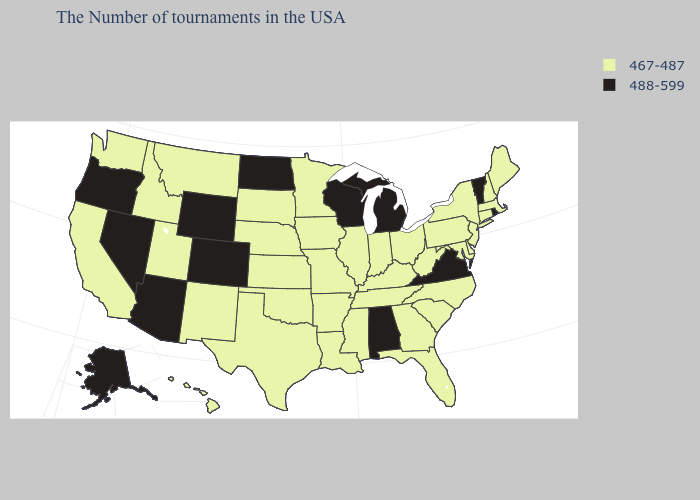Among the states that border Pennsylvania , which have the lowest value?
Short answer required. New York, New Jersey, Delaware, Maryland, West Virginia, Ohio. Does Montana have the lowest value in the West?
Write a very short answer. Yes. What is the value of Pennsylvania?
Give a very brief answer. 467-487. Which states have the lowest value in the USA?
Quick response, please. Maine, Massachusetts, New Hampshire, Connecticut, New York, New Jersey, Delaware, Maryland, Pennsylvania, North Carolina, South Carolina, West Virginia, Ohio, Florida, Georgia, Kentucky, Indiana, Tennessee, Illinois, Mississippi, Louisiana, Missouri, Arkansas, Minnesota, Iowa, Kansas, Nebraska, Oklahoma, Texas, South Dakota, New Mexico, Utah, Montana, Idaho, California, Washington, Hawaii. What is the lowest value in states that border Wyoming?
Be succinct. 467-487. Among the states that border Mississippi , which have the lowest value?
Quick response, please. Tennessee, Louisiana, Arkansas. What is the highest value in states that border Oregon?
Short answer required. 488-599. What is the value of Arkansas?
Short answer required. 467-487. What is the value of Arkansas?
Short answer required. 467-487. Among the states that border Oklahoma , which have the lowest value?
Concise answer only. Missouri, Arkansas, Kansas, Texas, New Mexico. Name the states that have a value in the range 467-487?
Write a very short answer. Maine, Massachusetts, New Hampshire, Connecticut, New York, New Jersey, Delaware, Maryland, Pennsylvania, North Carolina, South Carolina, West Virginia, Ohio, Florida, Georgia, Kentucky, Indiana, Tennessee, Illinois, Mississippi, Louisiana, Missouri, Arkansas, Minnesota, Iowa, Kansas, Nebraska, Oklahoma, Texas, South Dakota, New Mexico, Utah, Montana, Idaho, California, Washington, Hawaii. What is the lowest value in the Northeast?
Keep it brief. 467-487. 